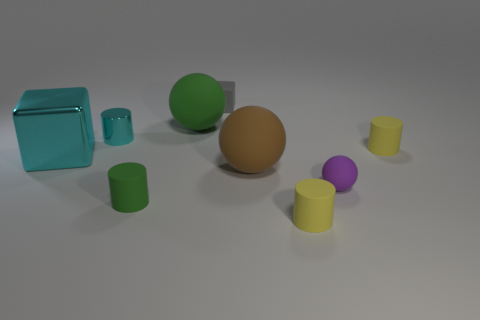What size is the green matte object that is left of the big green object?
Give a very brief answer. Small. What is the material of the tiny gray object?
Provide a short and direct response. Rubber. There is a yellow object behind the block in front of the tiny cyan cylinder; what is its shape?
Provide a short and direct response. Cylinder. How many other things are there of the same shape as the small gray rubber object?
Keep it short and to the point. 1. Are there any big green balls in front of the green rubber ball?
Your response must be concise. No. What is the color of the large block?
Offer a terse response. Cyan. There is a small ball; is its color the same as the matte cylinder that is behind the tiny green rubber cylinder?
Provide a short and direct response. No. Are there any green things that have the same size as the cyan shiny cube?
Provide a succinct answer. Yes. What is the size of the shiny cylinder that is the same color as the shiny block?
Your answer should be very brief. Small. What material is the green object that is to the left of the big green rubber ball?
Give a very brief answer. Rubber. 